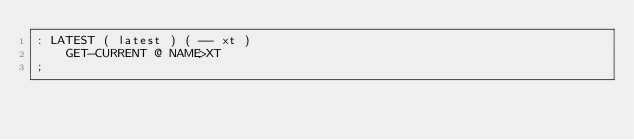Convert code to text. <code><loc_0><loc_0><loc_500><loc_500><_Forth_>: LATEST ( latest ) ( -- xt )
	GET-CURRENT @ NAME>XT
;
</code> 